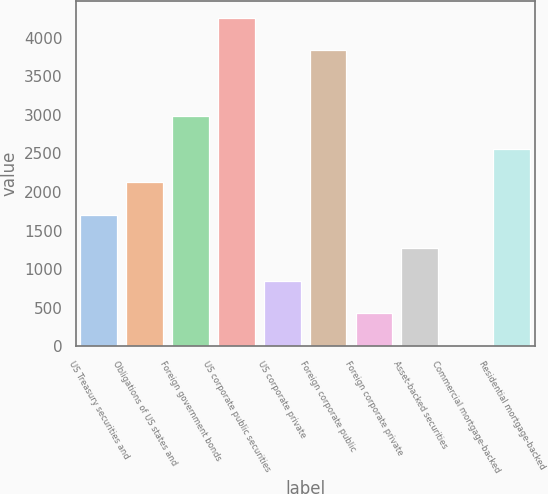Convert chart. <chart><loc_0><loc_0><loc_500><loc_500><bar_chart><fcel>US Treasury securities and<fcel>Obligations of US states and<fcel>Foreign government bonds<fcel>US corporate public securities<fcel>US corporate private<fcel>Foreign corporate public<fcel>Foreign corporate private<fcel>Asset-backed securities<fcel>Commercial mortgage-backed<fcel>Residential mortgage-backed<nl><fcel>1704.12<fcel>2129.93<fcel>2981.55<fcel>4258.98<fcel>852.5<fcel>3833.17<fcel>426.69<fcel>1278.31<fcel>0.88<fcel>2555.74<nl></chart> 